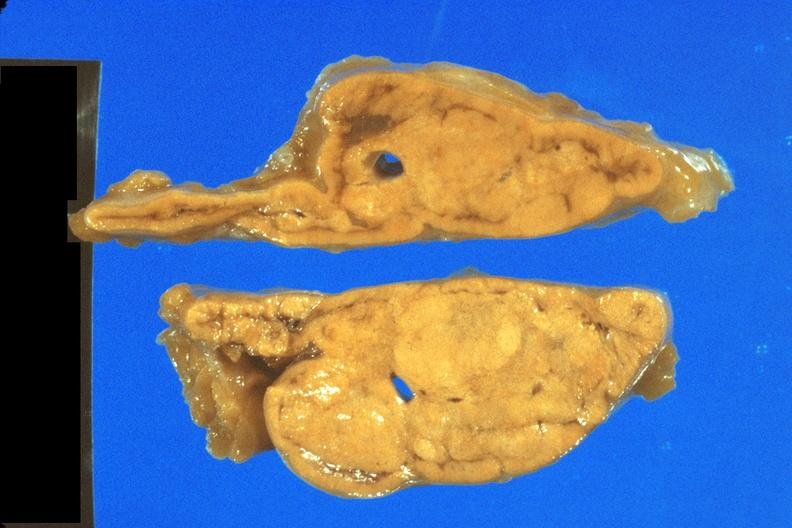does pituitary show fixed tissue nice close-up view of cortical nodules?
Answer the question using a single word or phrase. No 